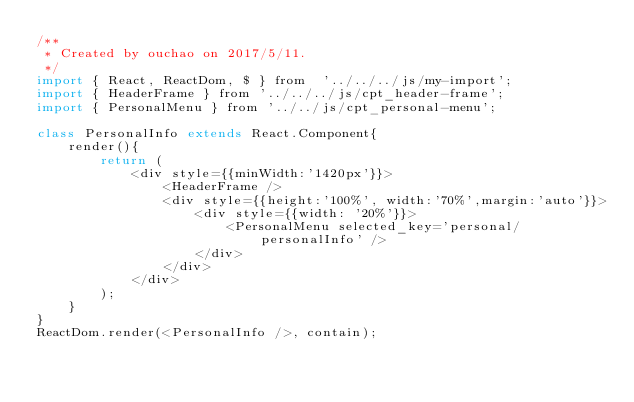<code> <loc_0><loc_0><loc_500><loc_500><_JavaScript_>/**
 * Created by ouchao on 2017/5/11.
 */
import { React, ReactDom, $ } from  '../../../js/my-import';
import { HeaderFrame } from '../../../js/cpt_header-frame';
import { PersonalMenu } from '../../js/cpt_personal-menu';

class PersonalInfo extends React.Component{
    render(){
        return (
            <div style={{minWidth:'1420px'}}>
                <HeaderFrame />
                <div style={{height:'100%', width:'70%',margin:'auto'}}>
                    <div style={{width: '20%'}}>
                        <PersonalMenu selected_key='personal/personalInfo' />
                    </div>
                </div>
            </div>
        );
    }
}
ReactDom.render(<PersonalInfo />, contain);</code> 